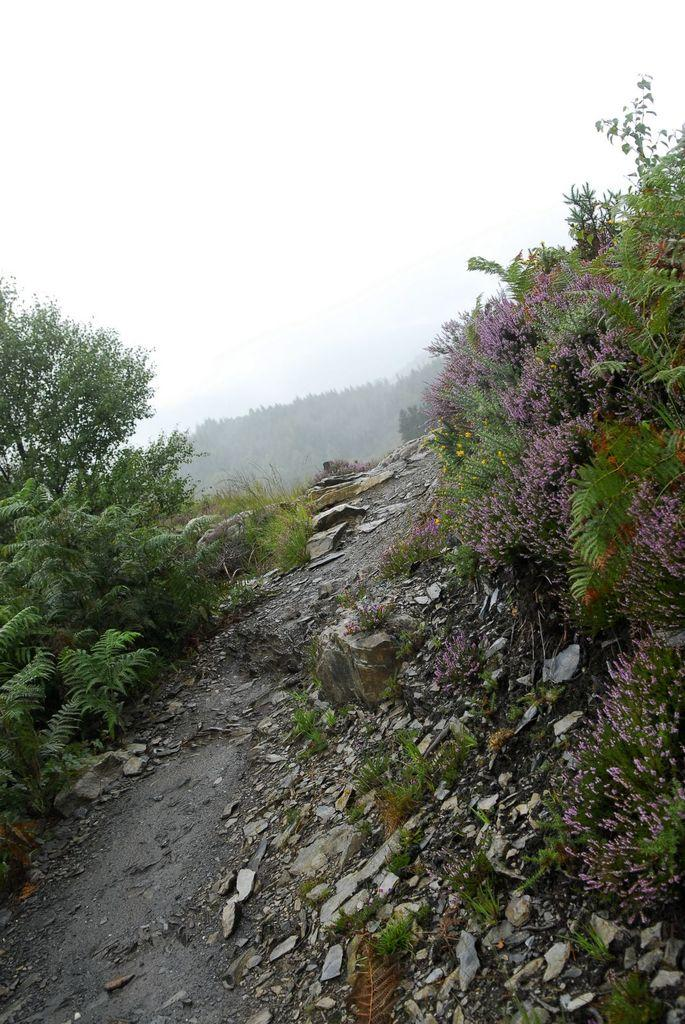What types of plants can be seen in the image? There are many plants in the image. What colors are the flowers on the plants? The flowers on the plants are yellow and purple. What can be seen in the background of the image? There are many trees and the sky visible in the background of the image. What organization is the grandmother fighting for in the image? There is no grandmother or organization present in the image. 